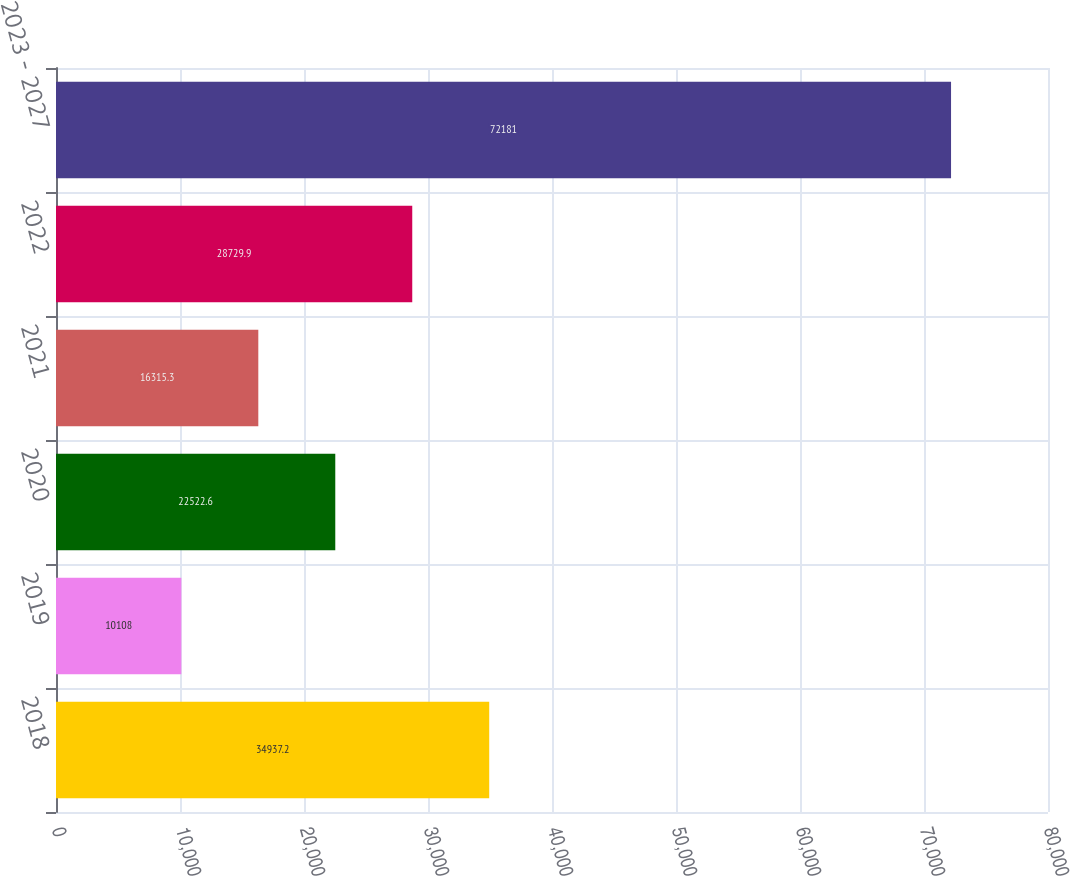Convert chart. <chart><loc_0><loc_0><loc_500><loc_500><bar_chart><fcel>2018<fcel>2019<fcel>2020<fcel>2021<fcel>2022<fcel>2023 - 2027<nl><fcel>34937.2<fcel>10108<fcel>22522.6<fcel>16315.3<fcel>28729.9<fcel>72181<nl></chart> 